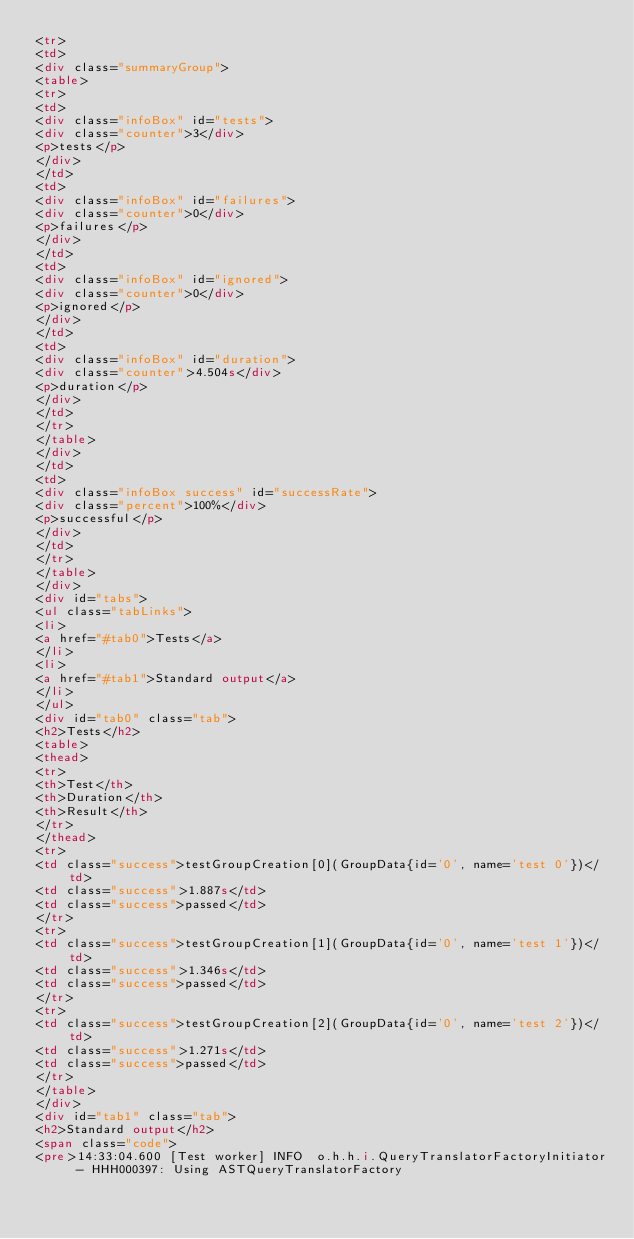<code> <loc_0><loc_0><loc_500><loc_500><_HTML_><tr>
<td>
<div class="summaryGroup">
<table>
<tr>
<td>
<div class="infoBox" id="tests">
<div class="counter">3</div>
<p>tests</p>
</div>
</td>
<td>
<div class="infoBox" id="failures">
<div class="counter">0</div>
<p>failures</p>
</div>
</td>
<td>
<div class="infoBox" id="ignored">
<div class="counter">0</div>
<p>ignored</p>
</div>
</td>
<td>
<div class="infoBox" id="duration">
<div class="counter">4.504s</div>
<p>duration</p>
</div>
</td>
</tr>
</table>
</div>
</td>
<td>
<div class="infoBox success" id="successRate">
<div class="percent">100%</div>
<p>successful</p>
</div>
</td>
</tr>
</table>
</div>
<div id="tabs">
<ul class="tabLinks">
<li>
<a href="#tab0">Tests</a>
</li>
<li>
<a href="#tab1">Standard output</a>
</li>
</ul>
<div id="tab0" class="tab">
<h2>Tests</h2>
<table>
<thead>
<tr>
<th>Test</th>
<th>Duration</th>
<th>Result</th>
</tr>
</thead>
<tr>
<td class="success">testGroupCreation[0](GroupData{id='0', name='test 0'})</td>
<td class="success">1.887s</td>
<td class="success">passed</td>
</tr>
<tr>
<td class="success">testGroupCreation[1](GroupData{id='0', name='test 1'})</td>
<td class="success">1.346s</td>
<td class="success">passed</td>
</tr>
<tr>
<td class="success">testGroupCreation[2](GroupData{id='0', name='test 2'})</td>
<td class="success">1.271s</td>
<td class="success">passed</td>
</tr>
</table>
</div>
<div id="tab1" class="tab">
<h2>Standard output</h2>
<span class="code">
<pre>14:33:04.600 [Test worker] INFO  o.h.h.i.QueryTranslatorFactoryInitiator - HHH000397: Using ASTQueryTranslatorFactory</code> 